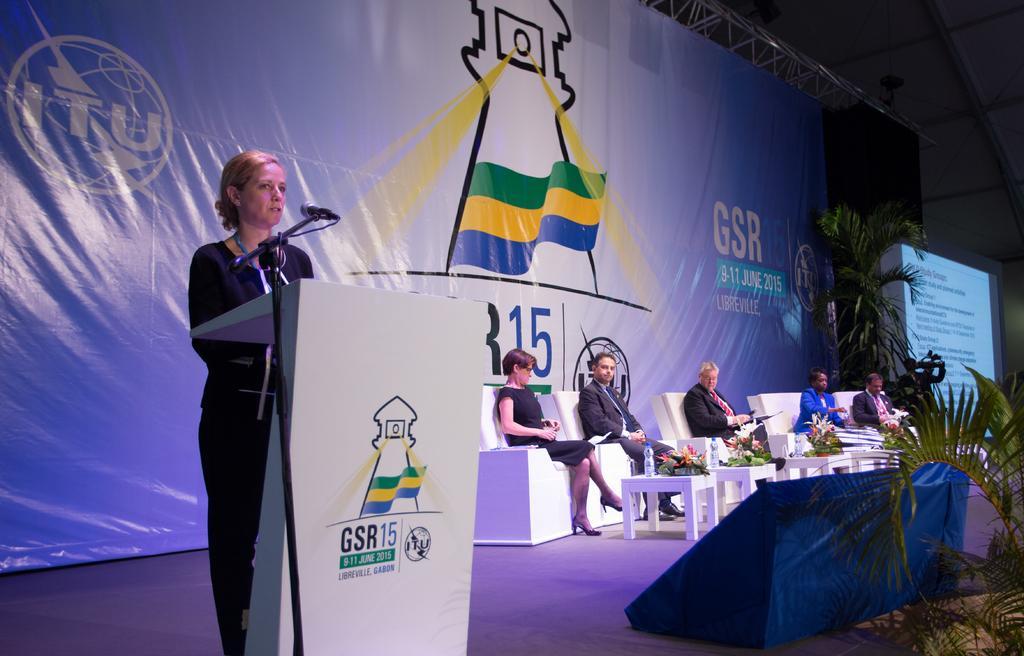Could you give a brief overview of what you see in this image? This picture is clicked in an auditorium. Woman on the right corner of the picture wearing black t-shirt is standing near the podium and she is talking on microphone. Beside her, we see five people sitting on chair and in front of them, we see table on which water bottle and flower pot are placed. Behind them, we see a board in blue color and beside that, we see projector screen with some text displayed on it. 